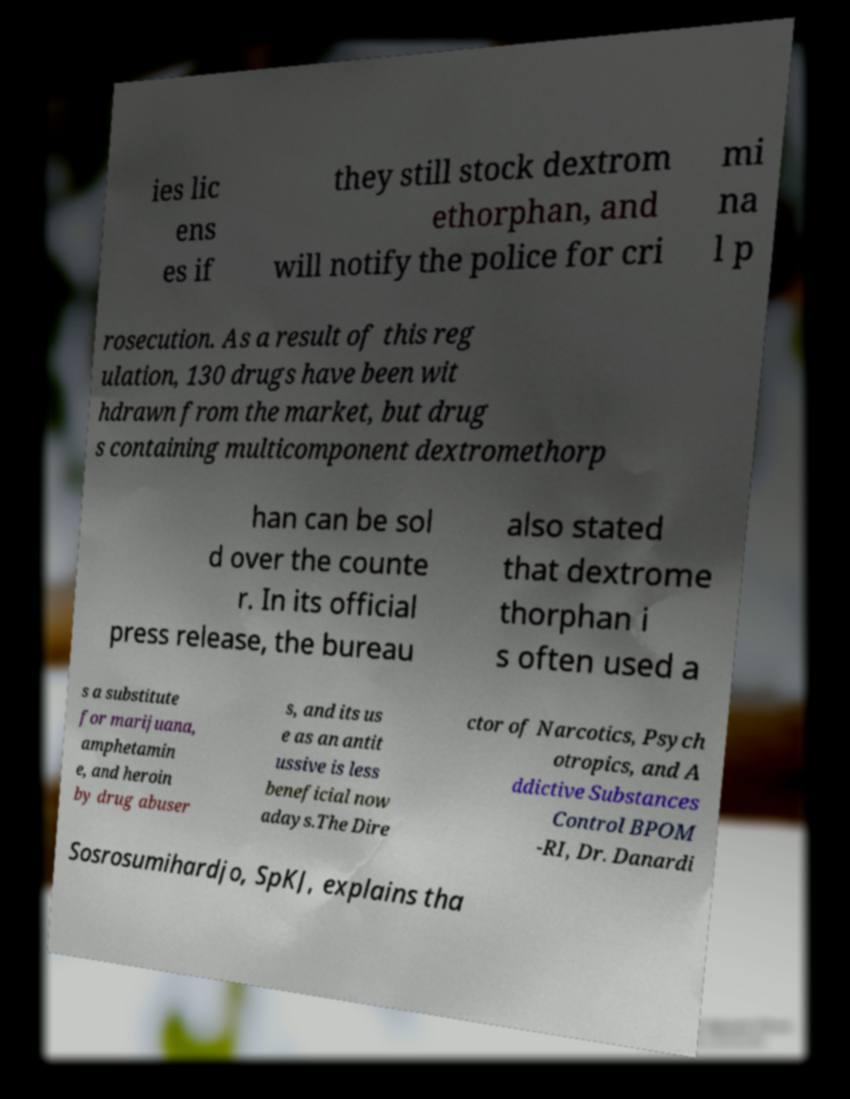I need the written content from this picture converted into text. Can you do that? ies lic ens es if they still stock dextrom ethorphan, and will notify the police for cri mi na l p rosecution. As a result of this reg ulation, 130 drugs have been wit hdrawn from the market, but drug s containing multicomponent dextromethorp han can be sol d over the counte r. In its official press release, the bureau also stated that dextrome thorphan i s often used a s a substitute for marijuana, amphetamin e, and heroin by drug abuser s, and its us e as an antit ussive is less beneficial now adays.The Dire ctor of Narcotics, Psych otropics, and A ddictive Substances Control BPOM -RI, Dr. Danardi Sosrosumihardjo, SpKJ, explains tha 